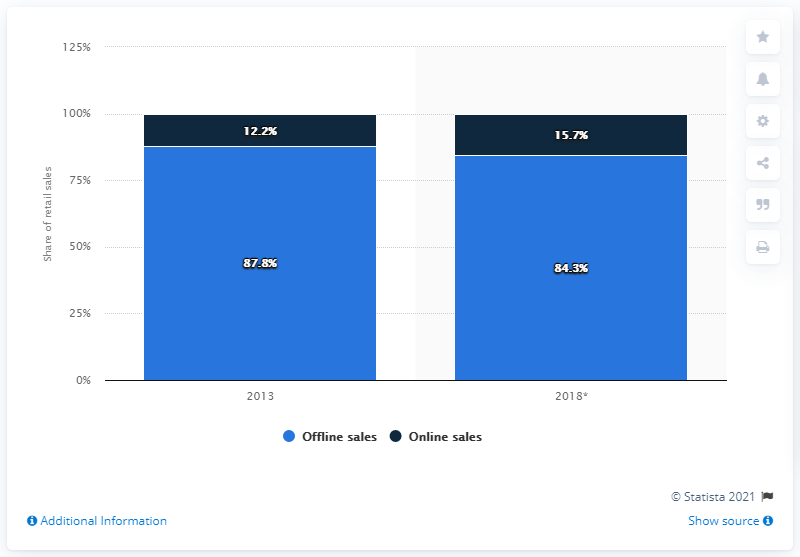Indicate a few pertinent items in this graphic. By 2018, it is predicted that there will be a significant increase in online sales of footwear in Germany, with a predicted increase of 15.7%. In 2013, online retail sales accounted for 12.2 percent of total footwear sales in Germany. In 2013, online sales of footwear accounted for 12.2% of total footwear sales. 